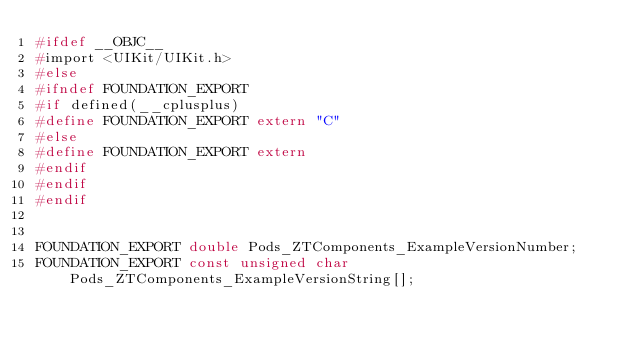<code> <loc_0><loc_0><loc_500><loc_500><_C_>#ifdef __OBJC__
#import <UIKit/UIKit.h>
#else
#ifndef FOUNDATION_EXPORT
#if defined(__cplusplus)
#define FOUNDATION_EXPORT extern "C"
#else
#define FOUNDATION_EXPORT extern
#endif
#endif
#endif


FOUNDATION_EXPORT double Pods_ZTComponents_ExampleVersionNumber;
FOUNDATION_EXPORT const unsigned char Pods_ZTComponents_ExampleVersionString[];

</code> 